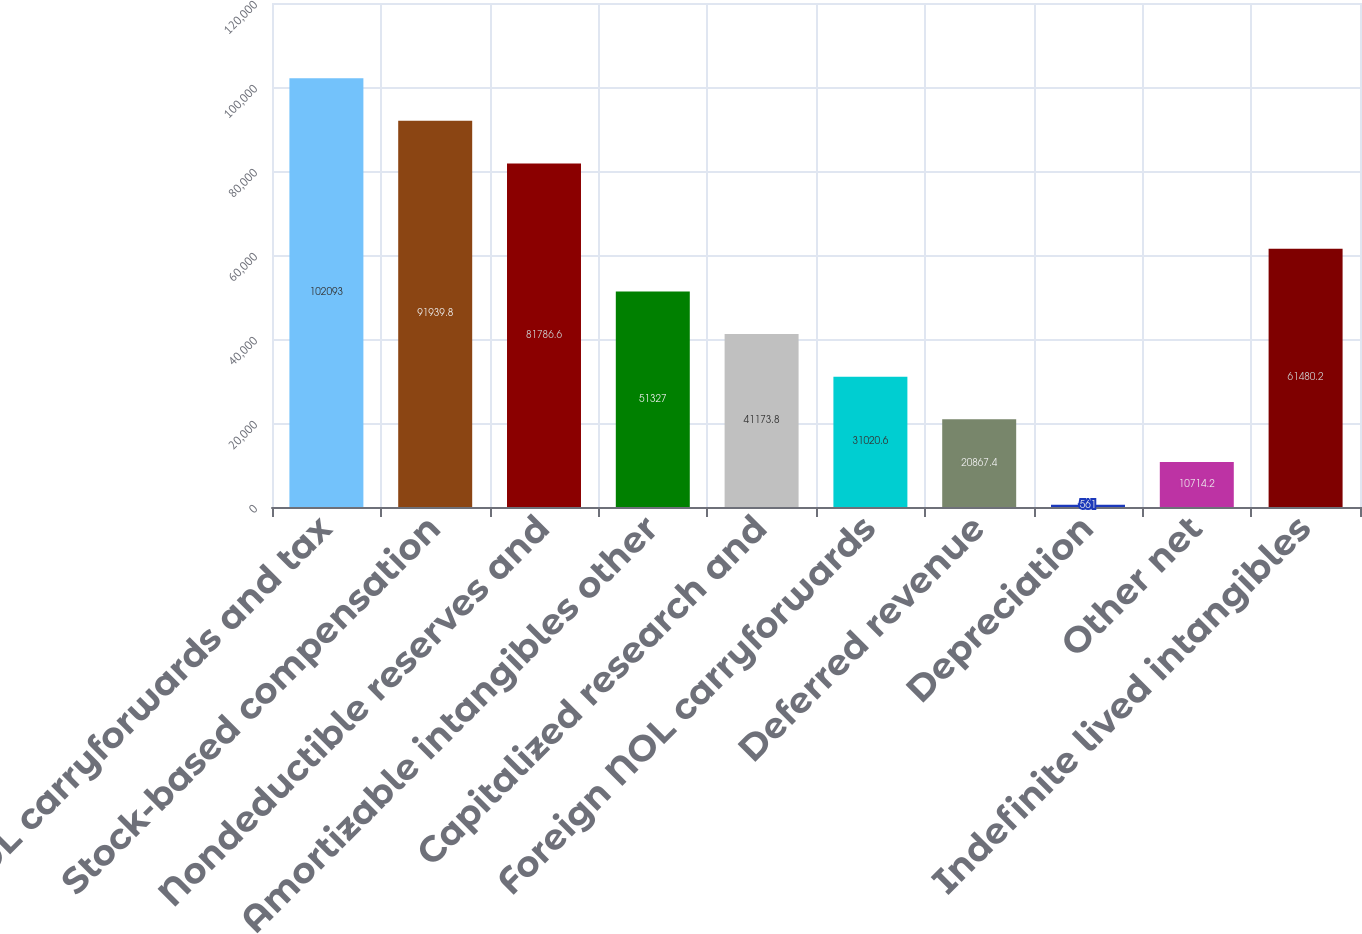Convert chart. <chart><loc_0><loc_0><loc_500><loc_500><bar_chart><fcel>NOL carryforwards and tax<fcel>Stock-based compensation<fcel>Nondeductible reserves and<fcel>Amortizable intangibles other<fcel>Capitalized research and<fcel>Foreign NOL carryforwards<fcel>Deferred revenue<fcel>Depreciation<fcel>Other net<fcel>Indefinite lived intangibles<nl><fcel>102093<fcel>91939.8<fcel>81786.6<fcel>51327<fcel>41173.8<fcel>31020.6<fcel>20867.4<fcel>561<fcel>10714.2<fcel>61480.2<nl></chart> 